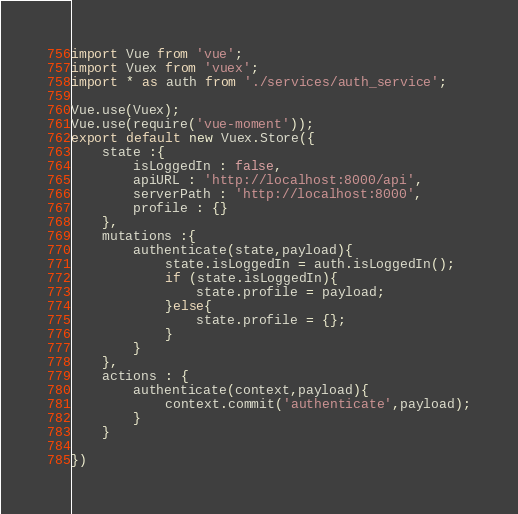<code> <loc_0><loc_0><loc_500><loc_500><_JavaScript_>import Vue from 'vue';
import Vuex from 'vuex';
import * as auth from './services/auth_service';

Vue.use(Vuex);
Vue.use(require('vue-moment'));
export default new Vuex.Store({
    state :{
        isLoggedIn : false,
        apiURL : 'http://localhost:8000/api',
        serverPath : 'http://localhost:8000',
        profile : {}
    },
    mutations :{
        authenticate(state,payload){
            state.isLoggedIn = auth.isLoggedIn();
            if (state.isLoggedIn){
                state.profile = payload;
            }else{
                state.profile = {};
            }
        }
    },
    actions : {
        authenticate(context,payload){
            context.commit('authenticate',payload);
        }
    }

})</code> 